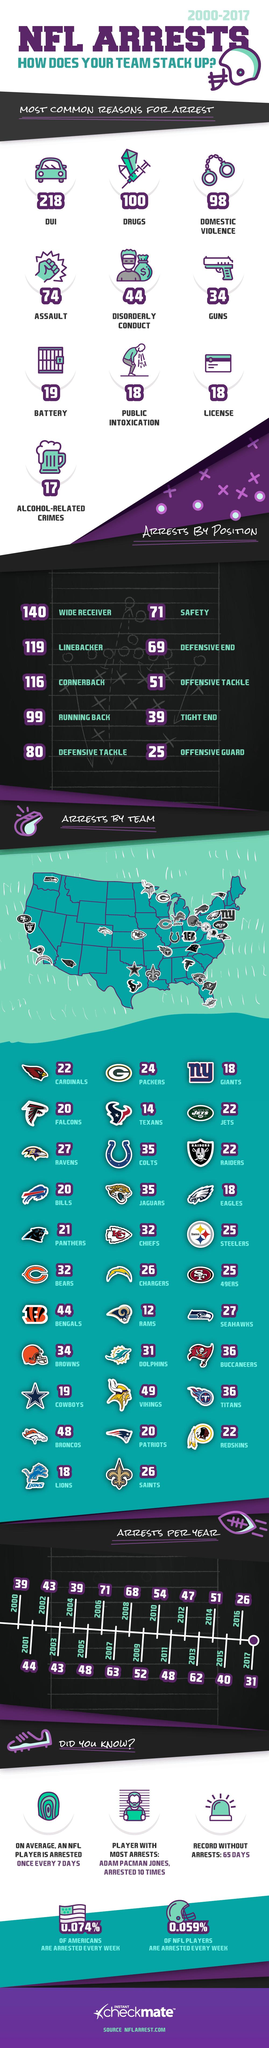Identify some key points in this picture. Offensive guards in the NFL have had the least number of arrests during the years 2000-2017. During the period of 2000 to 2017, the Dallas Cowboys NFL team reported a total of 19 arrests. DUI is the most common reason for the arrests of NFL players since 2000. There are 32 teams in the National Football League. During the 2000-2017 period, the NFL position with the highest number of arrests was wide receivers. 